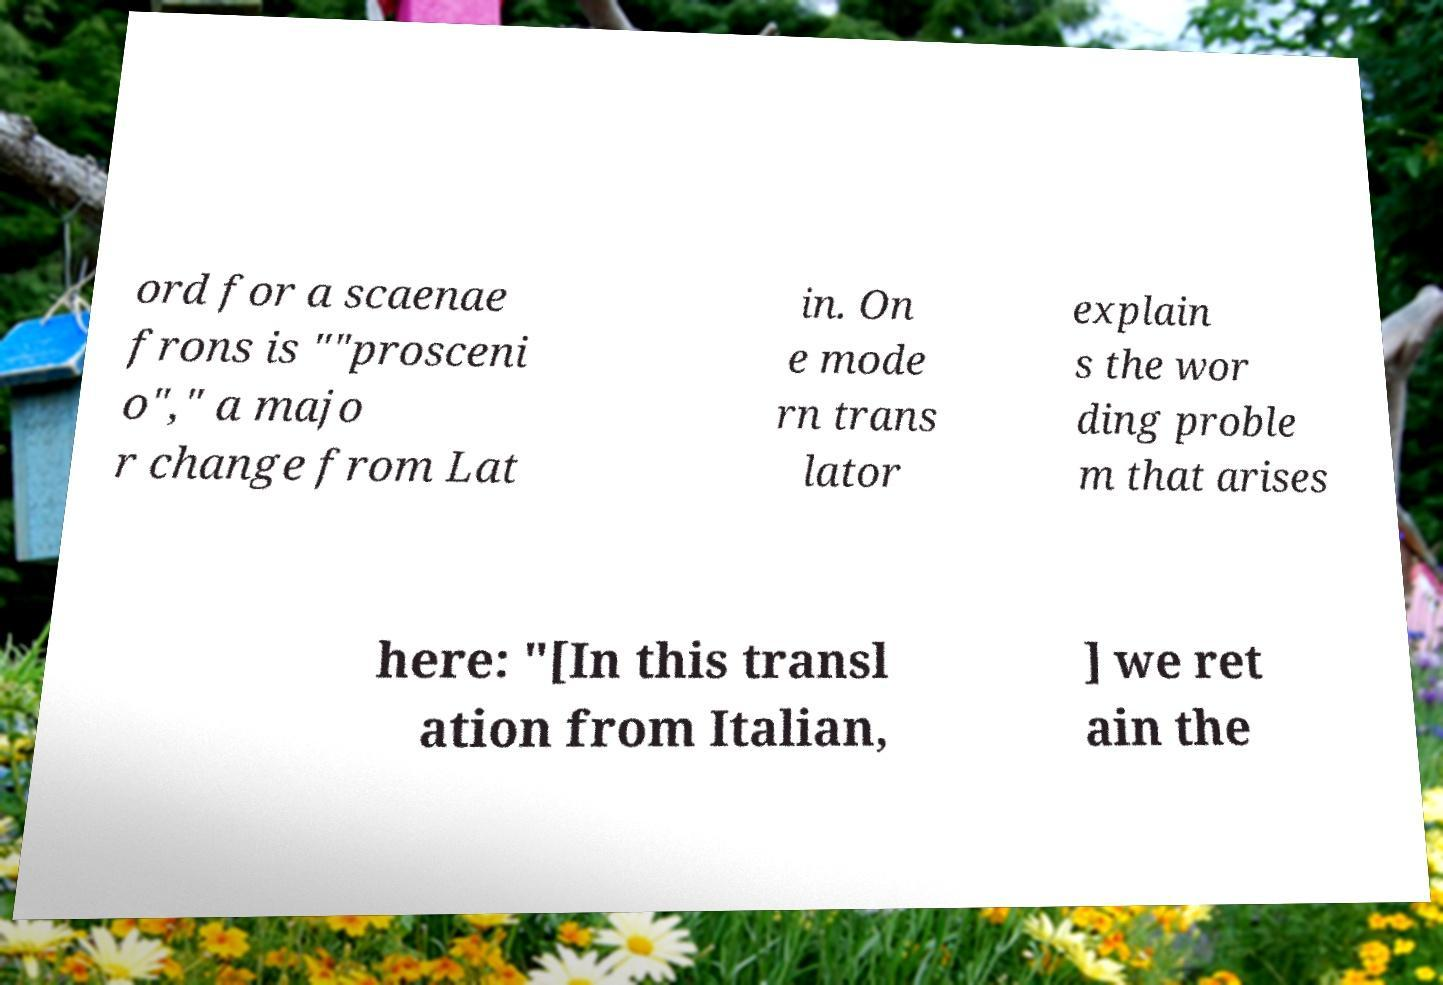Could you assist in decoding the text presented in this image and type it out clearly? ord for a scaenae frons is ""prosceni o"," a majo r change from Lat in. On e mode rn trans lator explain s the wor ding proble m that arises here: "[In this transl ation from Italian, ] we ret ain the 